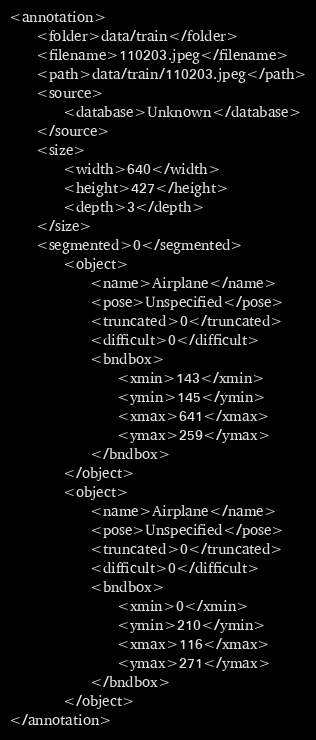Convert code to text. <code><loc_0><loc_0><loc_500><loc_500><_XML_>
<annotation>
    <folder>data/train</folder>
    <filename>110203.jpeg</filename>
    <path>data/train/110203.jpeg</path>
    <source>
        <database>Unknown</database>
    </source>
    <size>
        <width>640</width>
        <height>427</height>
        <depth>3</depth>
    </size>
    <segmented>0</segmented>
        <object>
            <name>Airplane</name>
            <pose>Unspecified</pose>
            <truncated>0</truncated>
            <difficult>0</difficult>
            <bndbox>
                <xmin>143</xmin>
                <ymin>145</ymin>
                <xmax>641</xmax>
                <ymax>259</ymax>
            </bndbox>
        </object>
        <object>
            <name>Airplane</name>
            <pose>Unspecified</pose>
            <truncated>0</truncated>
            <difficult>0</difficult>
            <bndbox>
                <xmin>0</xmin>
                <ymin>210</ymin>
                <xmax>116</xmax>
                <ymax>271</ymax>
            </bndbox>
        </object>
</annotation>
</code> 